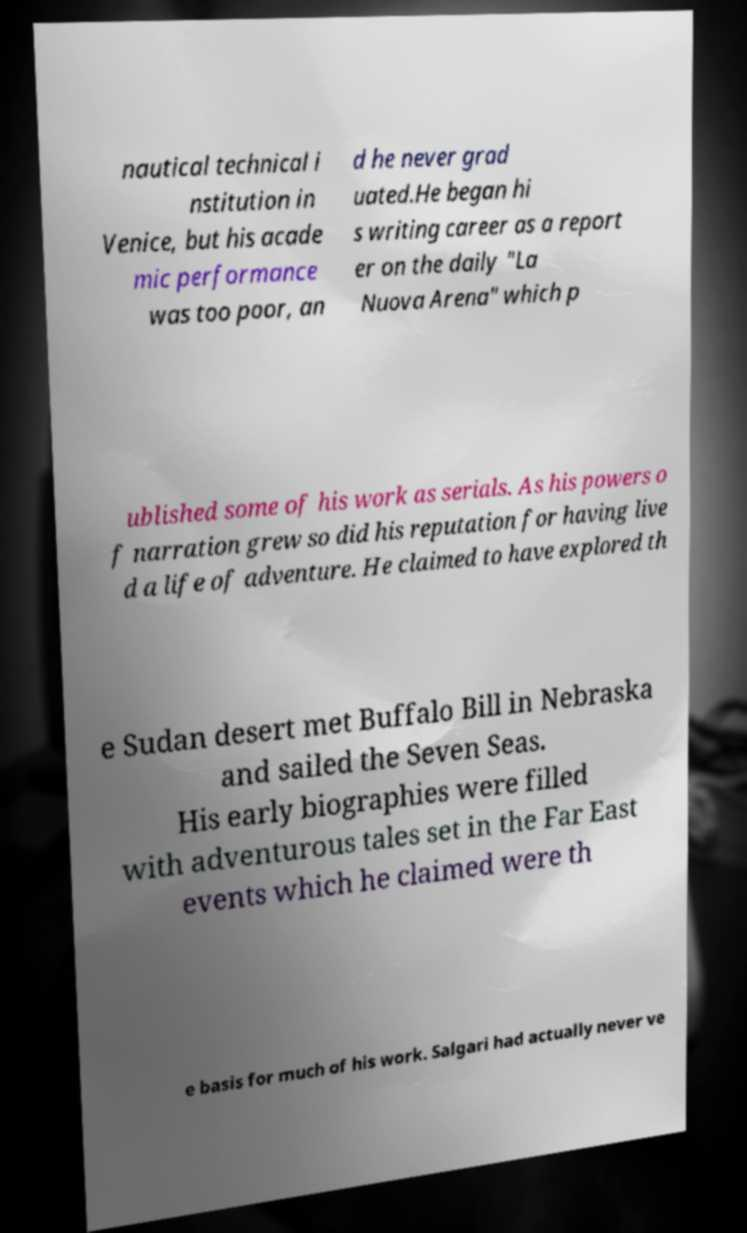What messages or text are displayed in this image? I need them in a readable, typed format. nautical technical i nstitution in Venice, but his acade mic performance was too poor, an d he never grad uated.He began hi s writing career as a report er on the daily "La Nuova Arena" which p ublished some of his work as serials. As his powers o f narration grew so did his reputation for having live d a life of adventure. He claimed to have explored th e Sudan desert met Buffalo Bill in Nebraska and sailed the Seven Seas. His early biographies were filled with adventurous tales set in the Far East events which he claimed were th e basis for much of his work. Salgari had actually never ve 